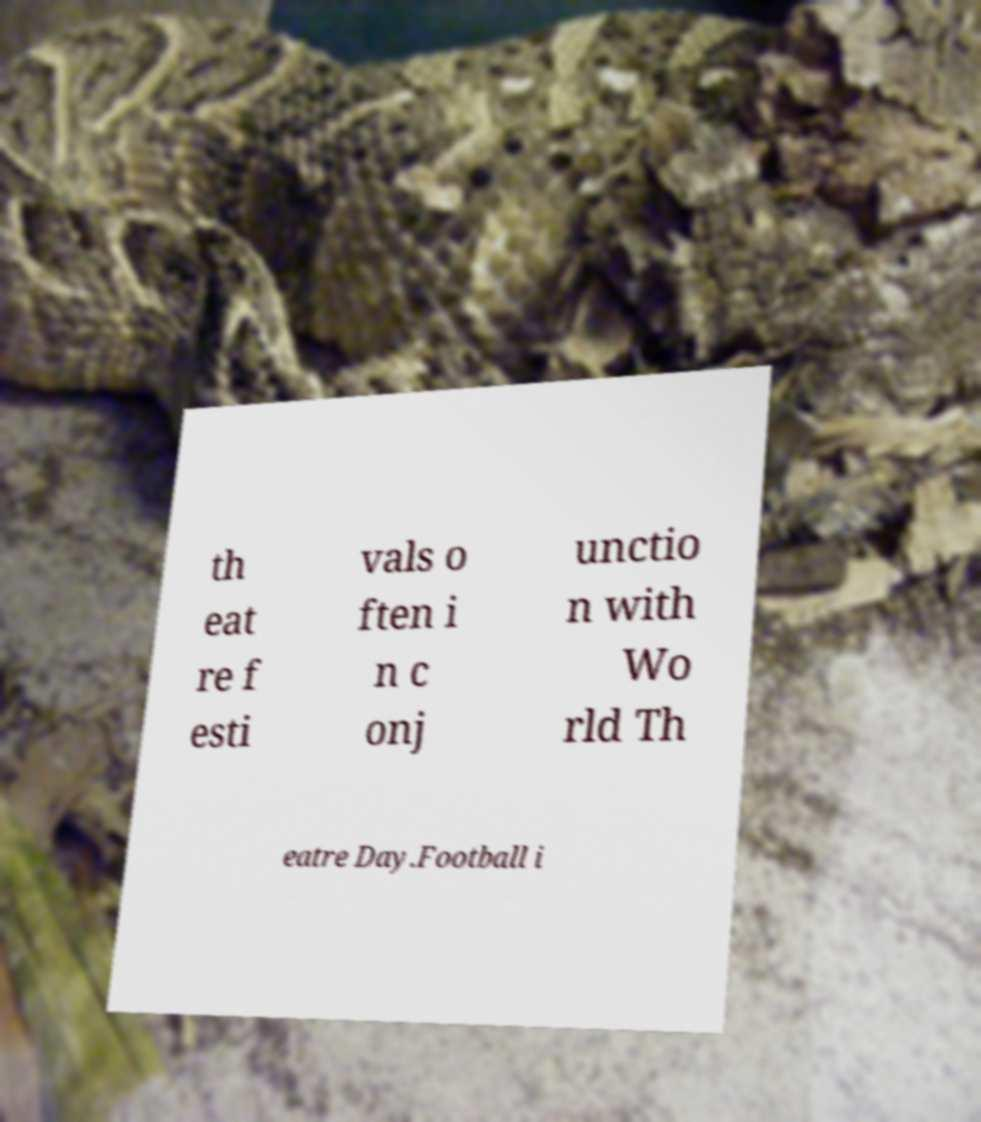Could you extract and type out the text from this image? th eat re f esti vals o ften i n c onj unctio n with Wo rld Th eatre Day.Football i 